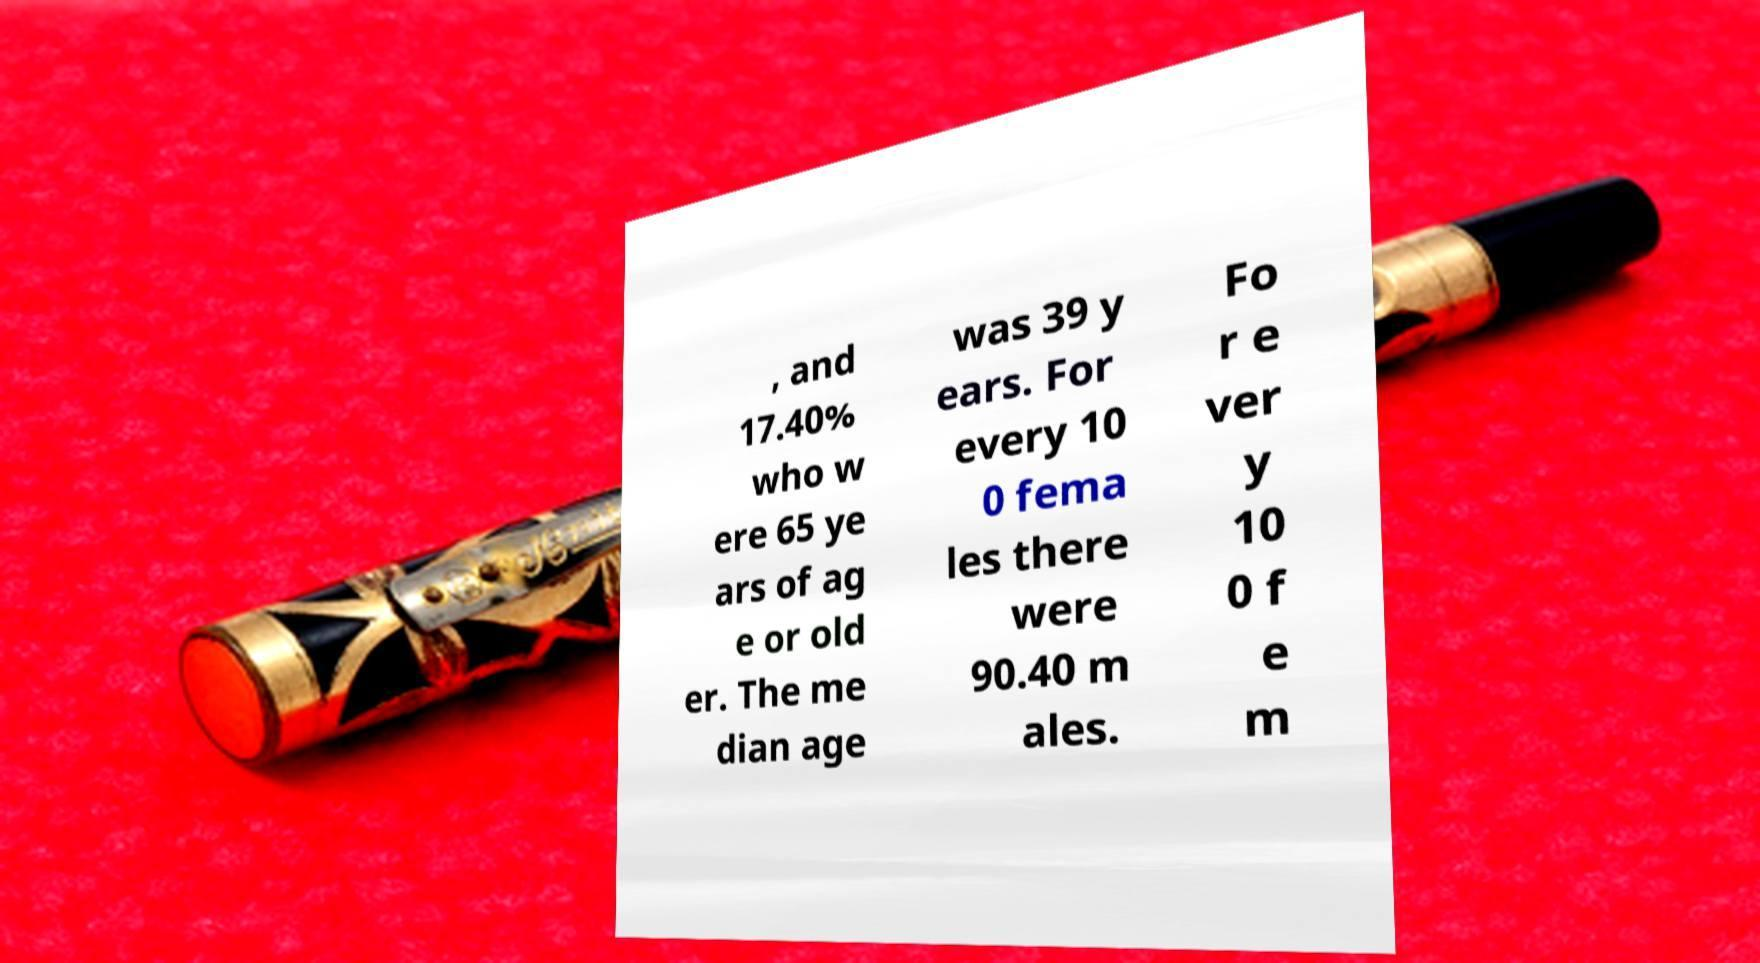Could you assist in decoding the text presented in this image and type it out clearly? , and 17.40% who w ere 65 ye ars of ag e or old er. The me dian age was 39 y ears. For every 10 0 fema les there were 90.40 m ales. Fo r e ver y 10 0 f e m 